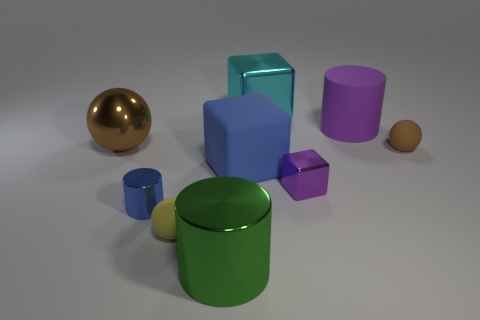How many things are large metallic objects that are to the left of the yellow thing or big metallic objects to the right of the tiny cylinder?
Offer a very short reply. 3. The brown matte thing that is the same size as the yellow rubber sphere is what shape?
Your answer should be very brief. Sphere. Are there any purple things that have the same shape as the green metal object?
Keep it short and to the point. Yes. Is the number of brown rubber things less than the number of tiny blue metal blocks?
Ensure brevity in your answer.  No. There is a sphere behind the tiny brown rubber sphere; is it the same size as the rubber ball that is behind the small yellow matte sphere?
Provide a succinct answer. No. How many things are tiny purple shiny cylinders or green objects?
Offer a terse response. 1. How big is the brown ball right of the small purple cube?
Ensure brevity in your answer.  Small. How many cyan shiny things are in front of the small thing that is on the right side of the large cylinder behind the brown matte object?
Ensure brevity in your answer.  0. Is the color of the big shiny cylinder the same as the large shiny block?
Provide a short and direct response. No. What number of big things are both to the right of the large cyan block and behind the big purple cylinder?
Provide a succinct answer. 0. 